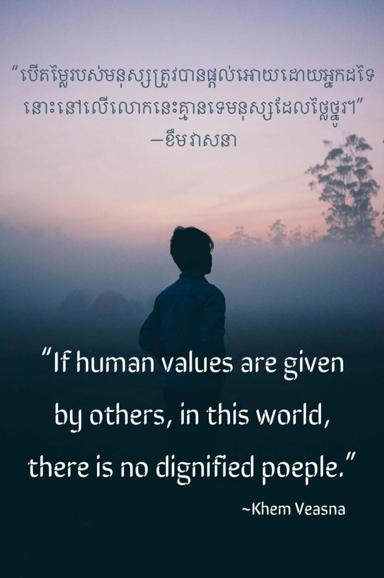What quote is mentioned in the image and who said it? The image features the quote, "If human values are given by others, in this world, there is no dignified people." This profound statement was made by Khem Veasna, a noted Cambodian politician known for his critical perspective on societal structures and the importance of individual autonomy in ethical development. 